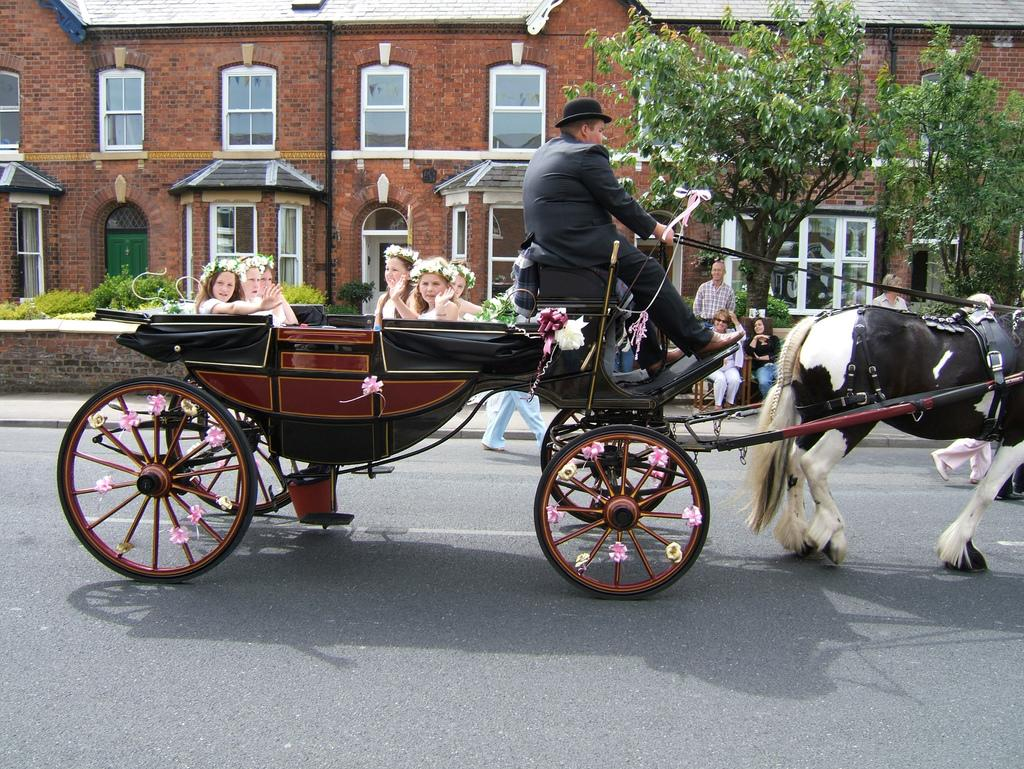What is the man in the image doing? The man is sitting and riding a horse cart in the image. What can be seen in the background of the image? There is a building, a tree, and plants in the background of the image. What type of credit does the man have on his dad's bread in the image? There is no mention of credit, dad, or bread in the image; it only features a man riding a horse cart with a background of a building, tree, and plants. 